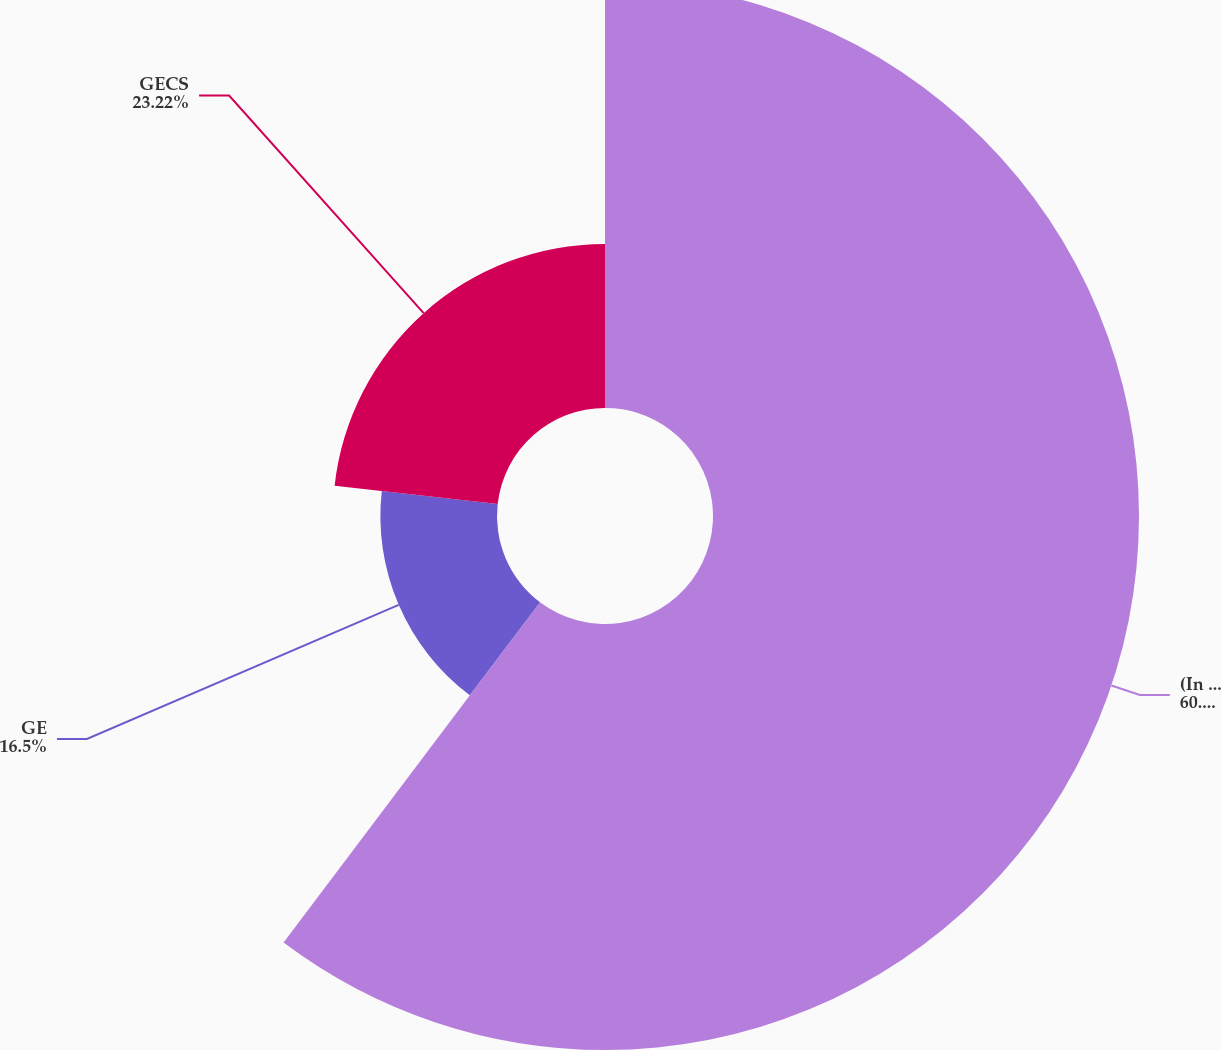Convert chart to OTSL. <chart><loc_0><loc_0><loc_500><loc_500><pie_chart><fcel>(In millions)<fcel>GE<fcel>GECS<nl><fcel>60.28%<fcel>16.5%<fcel>23.22%<nl></chart> 